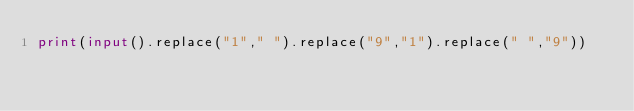<code> <loc_0><loc_0><loc_500><loc_500><_Python_>print(input().replace("1"," ").replace("9","1").replace(" ","9"))</code> 